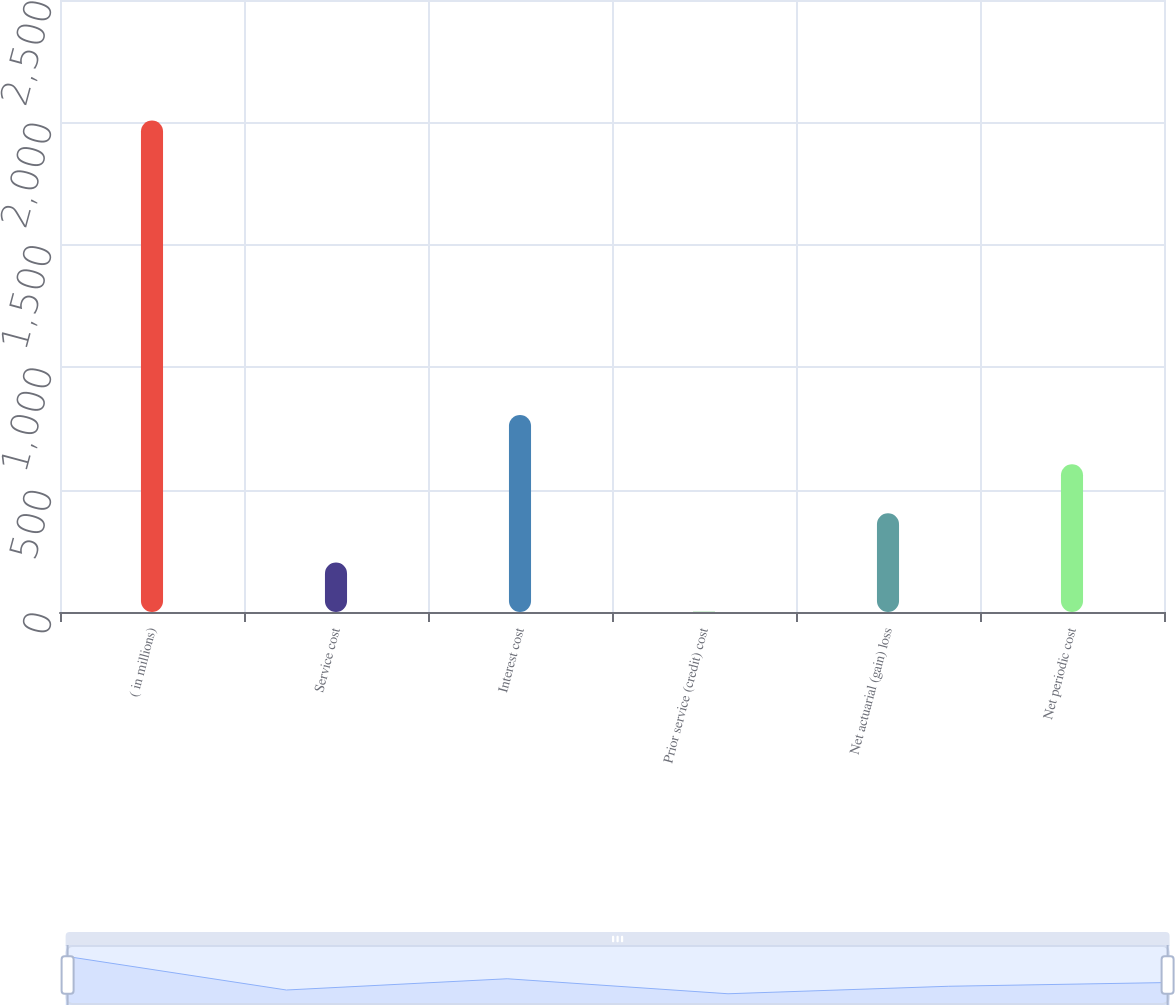Convert chart. <chart><loc_0><loc_0><loc_500><loc_500><bar_chart><fcel>( in millions)<fcel>Service cost<fcel>Interest cost<fcel>Prior service (credit) cost<fcel>Net actuarial (gain) loss<fcel>Net periodic cost<nl><fcel>2008<fcel>202.6<fcel>804.4<fcel>2<fcel>403.2<fcel>603.8<nl></chart> 